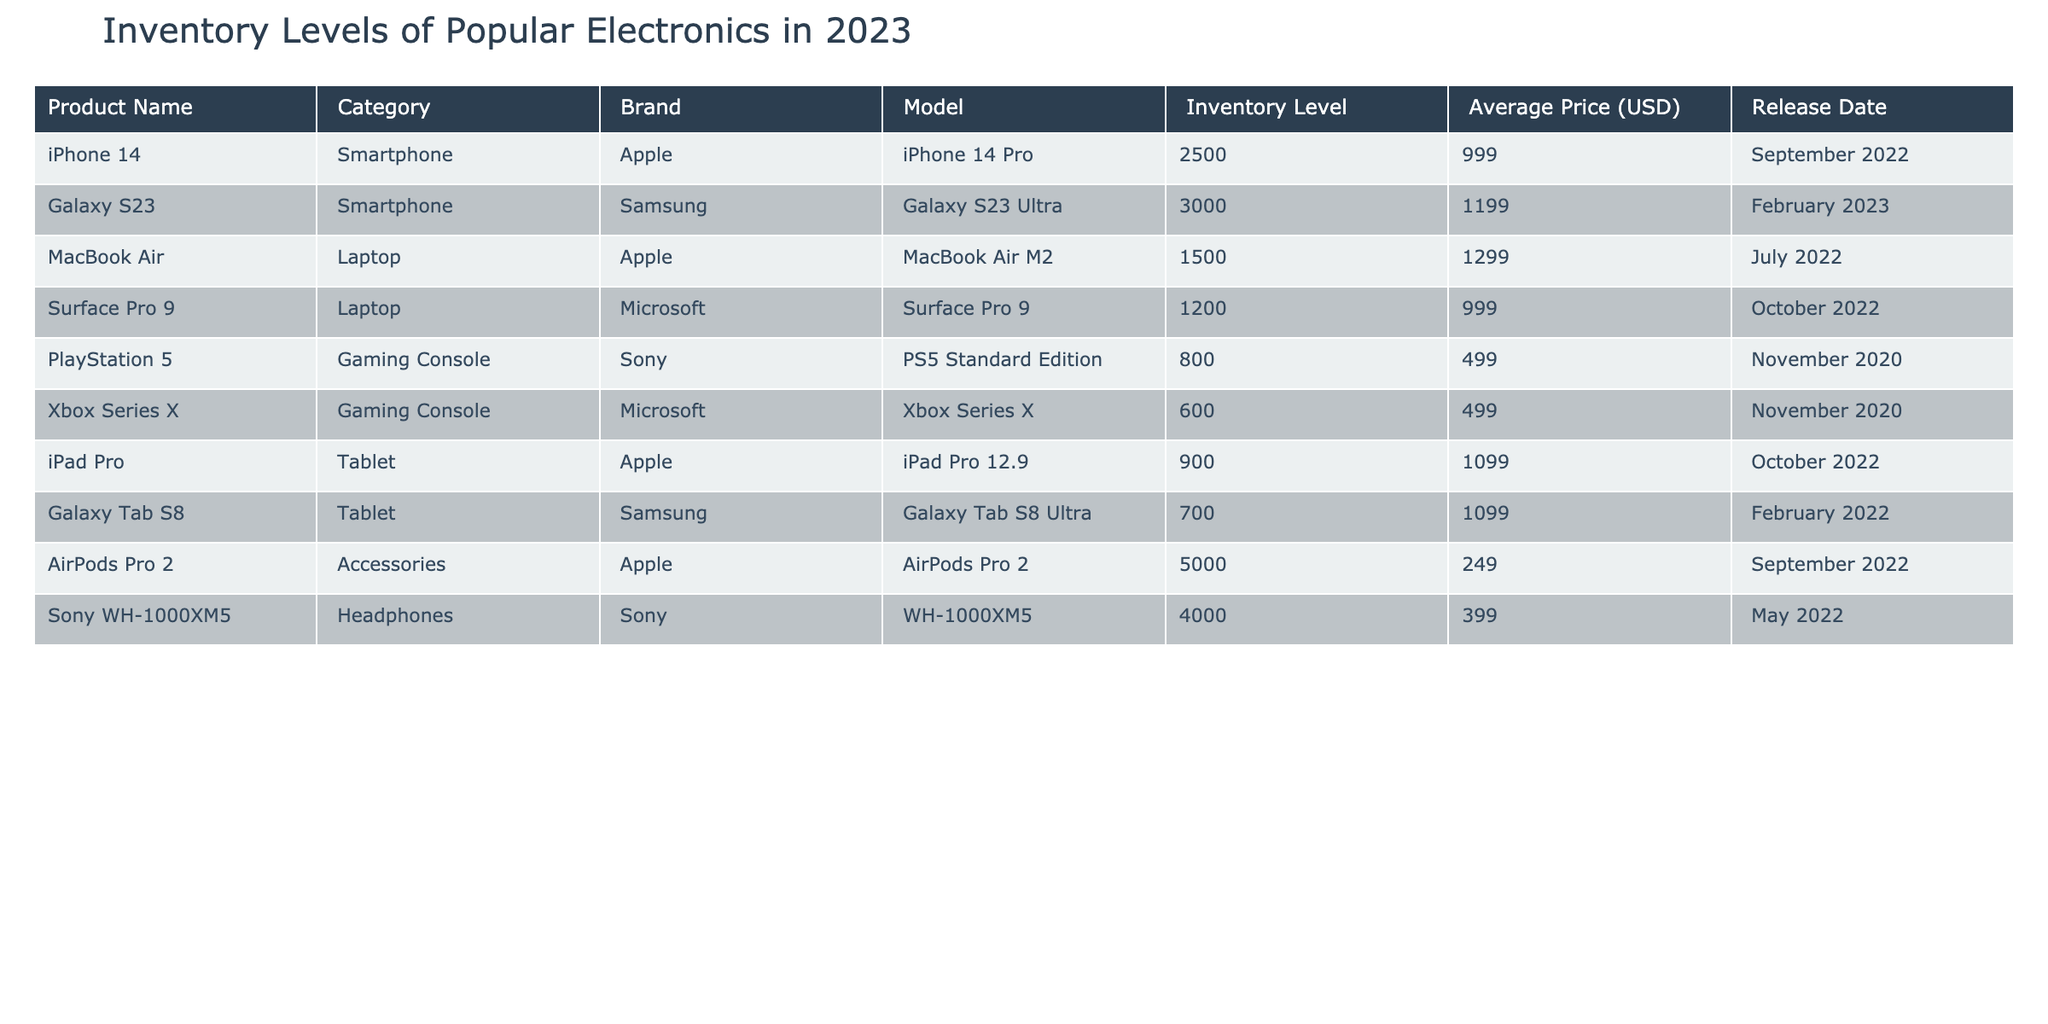What is the inventory level of the iPhone 14? The inventory level of the iPhone 14 can be found in the table under the 'Inventory Level' column for the row that lists the product name 'iPhone 14'. It shows 2500 units.
Answer: 2500 How many Xbox Series X units are there compared to PlayStation 5 units? The inventory levels for both the Xbox Series X and PlayStation 5 can be compared by checking their respective inventory levels. Xbox Series X has 600 units while PlayStation 5 has 800 units. The difference is calculated as 800 - 600 = 200.
Answer: 200 Which brand has the highest number of accessories in inventory? To determine the brand with the highest number of accessories, we check the 'Inventory Level' of the accessories listed. The AirPods Pro 2 under Apple has 5000 units and is the only accessory listed, so it is also the brand with the highest inventory for accessories.
Answer: Apple Is the average price of Samsung products lower than that of Apple products? First, we list the average prices of Samsung products: Galaxy S23 is 1199 and Galaxy Tab S8 is 1099, averaging (1199 + 1099)/2 = 1149. Apple products average: iPhone 14 is 999, MacBook Air is 1299, and iPad Pro is 1099, averaging (999 + 1299 + 1099)/3 = 1099. Since 1149 is greater than 1099, the fact is false.
Answer: No How many units of tablets are there in total? To find the total inventory level of tablets, we look for the tablet products listed: iPad Pro has 900 units and Galaxy Tab S8 has 700 units. Adding them yields 900 + 700 = 1600.
Answer: 1600 What is the average inventory level of gaming consoles? The inventory levels of gaming consoles are: PlayStation 5 has 800 units and Xbox Series X has 600 units. To find the average, we calculate (800 + 600)/2 = 700.
Answer: 700 Does the Surface Pro 9 have a higher inventory level than the MacBook Air? Checking the inventory level, the Surface Pro 9 has 1200 units while the MacBook Air has 1500 units. Therefore, the statement that Surface Pro 9 has a higher inventory level is false.
Answer: No What is the total inventory of all Apple products? The Apple products listed are iPhone 14 (2500), MacBook Air (1500), iPad Pro (900), and AirPods Pro 2 (5000). Adding these gives 2500 + 1500 + 900 + 5000 = 9900.
Answer: 9900 How does the average price of headphones compare to the average price of smartphones? The average price for headphones: Sony WH-1000XM5 costs 399. Average smartphone prices are: iPhone 14 at 999 and Galaxy S23 at 1199. Average for smartphones is (999 + 1199)/2 = 1099. Since 399 is less than 1099, the average price of headphones is lower.
Answer: Yes 